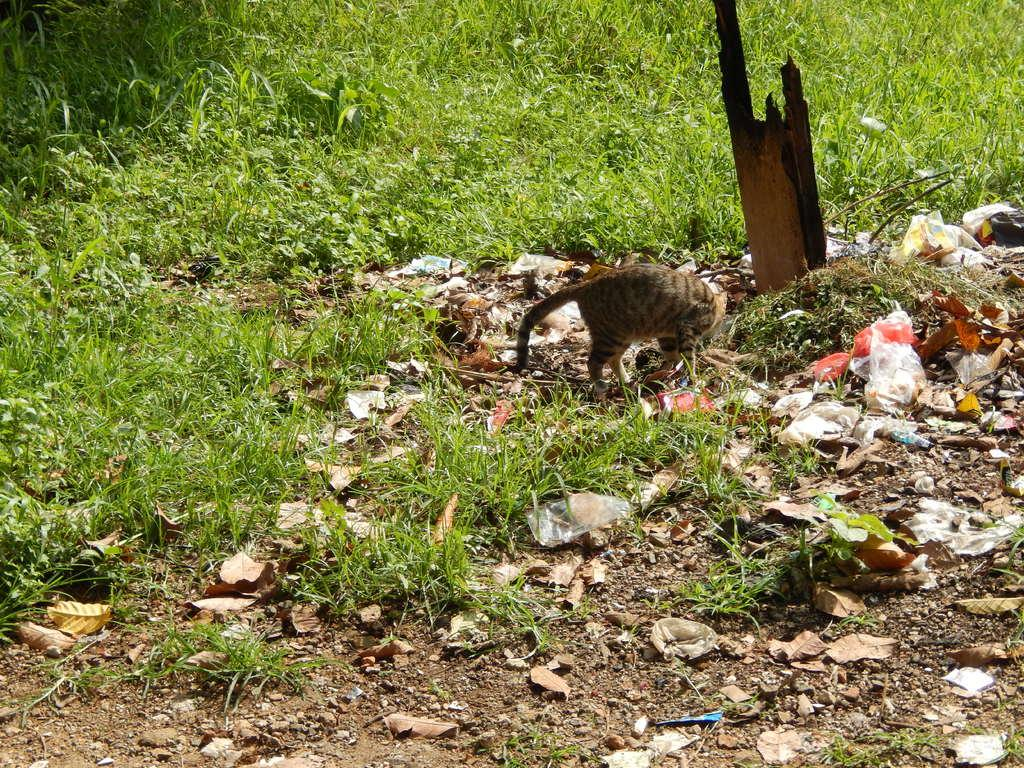What type of animal can be seen in the image? There is a cat in the image. What objects are covering something in the image? There are plastic covers in the image. What natural elements are present on the ground in the image? Dried leaves are present on the ground in the image. What type of vegetation can be seen in the background of the image? There is grass visible in the background of the image. What color is the skirt worn by the cat in the image? There is no skirt present in the image, as the subject is a cat and not a person. 